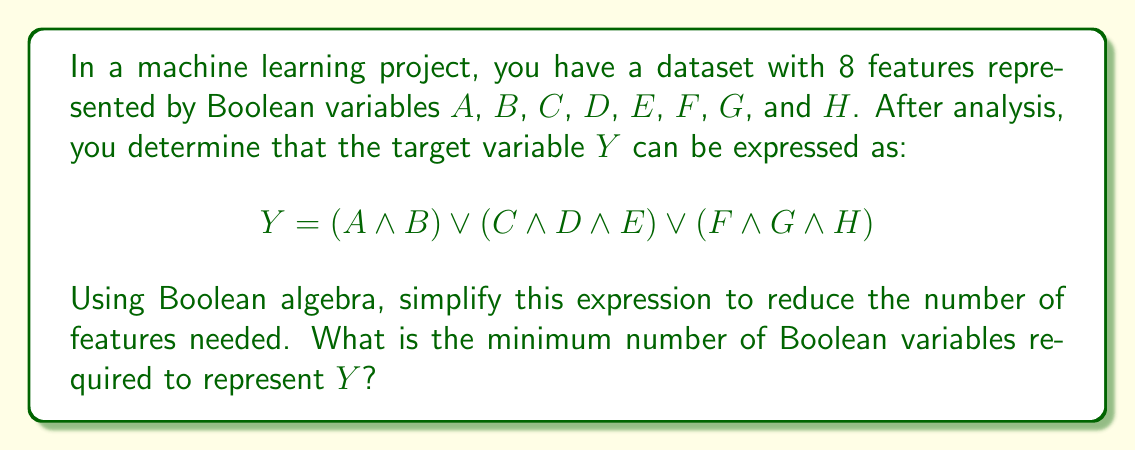Give your solution to this math problem. Let's approach this step-by-step:

1) First, we can introduce new variables to represent each term:
   Let $P = A \land B$
   Let $Q = C \land D \land E$
   Let $R = F \land G \land H$

   Now, $Y = P \lor Q \lor R$

2) This is already in disjunctive normal form (DNF), which is often used in feature selection.

3) We can't further simplify this expression using Boolean algebra laws without losing information.

4) Each term ($P$, $Q$, $R$) represents a composite feature:
   - $P$ requires 2 original features
   - $Q$ requires 3 original features
   - $R$ requires 3 original features

5) Instead of using 8 original features, we can use these 3 composite features.

6) Therefore, the minimum number of Boolean variables required to represent $Y$ is 3.

This process demonstrates dimensionality reduction, as we've reduced the feature space from 8 dimensions to 3 dimensions while preserving the necessary information for predicting $Y$.
Answer: 3 